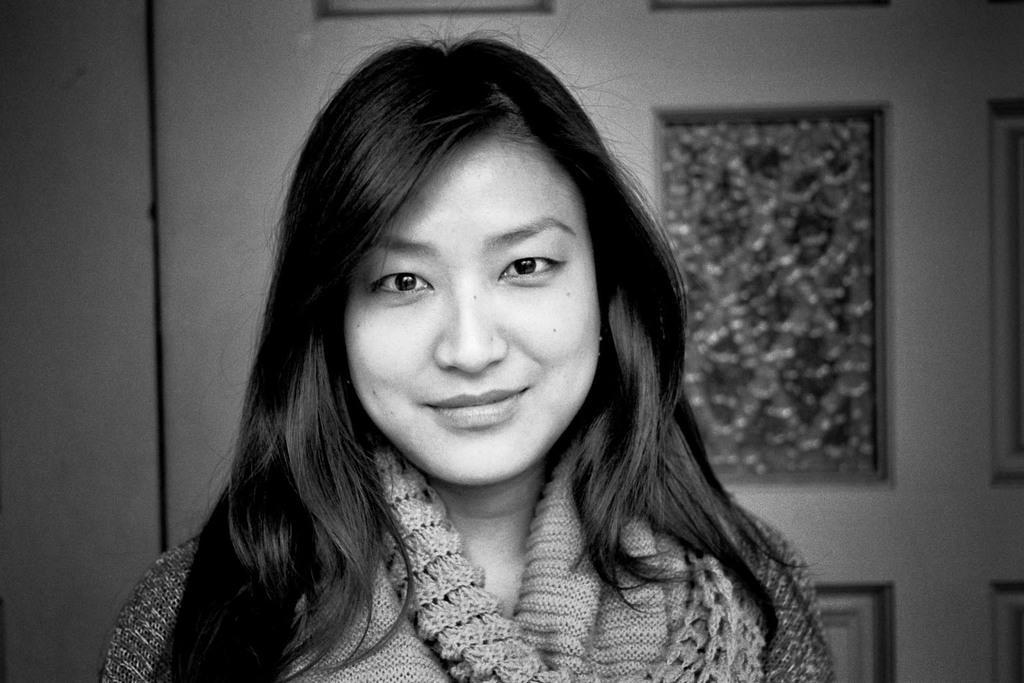Could you give a brief overview of what you see in this image? In the center of the image we can see a lady smiling. In the background there is a wall and a door. 